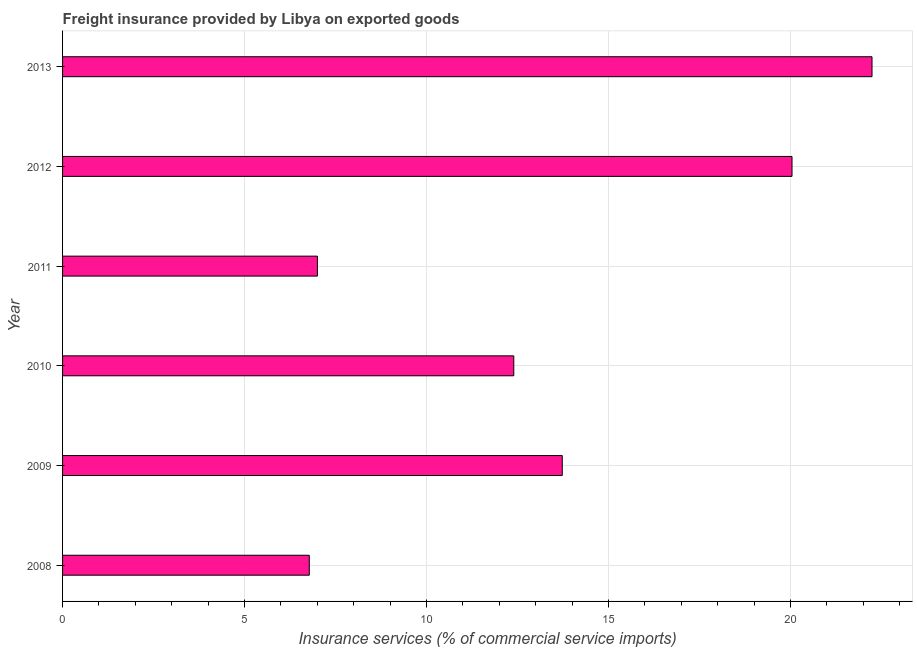Does the graph contain any zero values?
Your answer should be very brief. No. What is the title of the graph?
Keep it short and to the point. Freight insurance provided by Libya on exported goods . What is the label or title of the X-axis?
Give a very brief answer. Insurance services (% of commercial service imports). What is the label or title of the Y-axis?
Make the answer very short. Year. What is the freight insurance in 2009?
Offer a very short reply. 13.73. Across all years, what is the maximum freight insurance?
Your answer should be very brief. 22.24. Across all years, what is the minimum freight insurance?
Ensure brevity in your answer.  6.78. In which year was the freight insurance maximum?
Give a very brief answer. 2013. What is the sum of the freight insurance?
Give a very brief answer. 82.19. What is the difference between the freight insurance in 2011 and 2012?
Your answer should be compact. -13.04. What is the average freight insurance per year?
Your answer should be very brief. 13.7. What is the median freight insurance?
Ensure brevity in your answer.  13.06. In how many years, is the freight insurance greater than 19 %?
Your answer should be compact. 2. Do a majority of the years between 2010 and 2012 (inclusive) have freight insurance greater than 8 %?
Your answer should be compact. Yes. What is the ratio of the freight insurance in 2008 to that in 2013?
Provide a succinct answer. 0.3. Is the difference between the freight insurance in 2010 and 2012 greater than the difference between any two years?
Keep it short and to the point. No. What is the difference between the highest and the second highest freight insurance?
Give a very brief answer. 2.2. Is the sum of the freight insurance in 2008 and 2010 greater than the maximum freight insurance across all years?
Your response must be concise. No. What is the difference between the highest and the lowest freight insurance?
Make the answer very short. 15.46. In how many years, is the freight insurance greater than the average freight insurance taken over all years?
Your response must be concise. 3. How many bars are there?
Your answer should be very brief. 6. Are all the bars in the graph horizontal?
Your answer should be compact. Yes. What is the Insurance services (% of commercial service imports) of 2008?
Provide a short and direct response. 6.78. What is the Insurance services (% of commercial service imports) of 2009?
Your answer should be very brief. 13.73. What is the Insurance services (% of commercial service imports) in 2010?
Offer a terse response. 12.4. What is the Insurance services (% of commercial service imports) of 2011?
Offer a terse response. 7. What is the Insurance services (% of commercial service imports) of 2012?
Offer a very short reply. 20.04. What is the Insurance services (% of commercial service imports) in 2013?
Offer a terse response. 22.24. What is the difference between the Insurance services (% of commercial service imports) in 2008 and 2009?
Your answer should be very brief. -6.95. What is the difference between the Insurance services (% of commercial service imports) in 2008 and 2010?
Give a very brief answer. -5.62. What is the difference between the Insurance services (% of commercial service imports) in 2008 and 2011?
Offer a very short reply. -0.22. What is the difference between the Insurance services (% of commercial service imports) in 2008 and 2012?
Your response must be concise. -13.26. What is the difference between the Insurance services (% of commercial service imports) in 2008 and 2013?
Your response must be concise. -15.46. What is the difference between the Insurance services (% of commercial service imports) in 2009 and 2010?
Your answer should be compact. 1.33. What is the difference between the Insurance services (% of commercial service imports) in 2009 and 2011?
Offer a very short reply. 6.73. What is the difference between the Insurance services (% of commercial service imports) in 2009 and 2012?
Offer a terse response. -6.31. What is the difference between the Insurance services (% of commercial service imports) in 2009 and 2013?
Ensure brevity in your answer.  -8.51. What is the difference between the Insurance services (% of commercial service imports) in 2010 and 2011?
Provide a short and direct response. 5.39. What is the difference between the Insurance services (% of commercial service imports) in 2010 and 2012?
Your answer should be compact. -7.64. What is the difference between the Insurance services (% of commercial service imports) in 2010 and 2013?
Ensure brevity in your answer.  -9.84. What is the difference between the Insurance services (% of commercial service imports) in 2011 and 2012?
Your answer should be very brief. -13.04. What is the difference between the Insurance services (% of commercial service imports) in 2011 and 2013?
Your answer should be very brief. -15.24. What is the difference between the Insurance services (% of commercial service imports) in 2012 and 2013?
Keep it short and to the point. -2.2. What is the ratio of the Insurance services (% of commercial service imports) in 2008 to that in 2009?
Provide a short and direct response. 0.49. What is the ratio of the Insurance services (% of commercial service imports) in 2008 to that in 2010?
Offer a terse response. 0.55. What is the ratio of the Insurance services (% of commercial service imports) in 2008 to that in 2012?
Give a very brief answer. 0.34. What is the ratio of the Insurance services (% of commercial service imports) in 2008 to that in 2013?
Offer a very short reply. 0.3. What is the ratio of the Insurance services (% of commercial service imports) in 2009 to that in 2010?
Offer a terse response. 1.11. What is the ratio of the Insurance services (% of commercial service imports) in 2009 to that in 2011?
Provide a succinct answer. 1.96. What is the ratio of the Insurance services (% of commercial service imports) in 2009 to that in 2012?
Offer a very short reply. 0.69. What is the ratio of the Insurance services (% of commercial service imports) in 2009 to that in 2013?
Keep it short and to the point. 0.62. What is the ratio of the Insurance services (% of commercial service imports) in 2010 to that in 2011?
Give a very brief answer. 1.77. What is the ratio of the Insurance services (% of commercial service imports) in 2010 to that in 2012?
Provide a short and direct response. 0.62. What is the ratio of the Insurance services (% of commercial service imports) in 2010 to that in 2013?
Your response must be concise. 0.56. What is the ratio of the Insurance services (% of commercial service imports) in 2011 to that in 2012?
Offer a terse response. 0.35. What is the ratio of the Insurance services (% of commercial service imports) in 2011 to that in 2013?
Your response must be concise. 0.32. What is the ratio of the Insurance services (% of commercial service imports) in 2012 to that in 2013?
Offer a terse response. 0.9. 